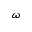<formula> <loc_0><loc_0><loc_500><loc_500>\omega</formula> 